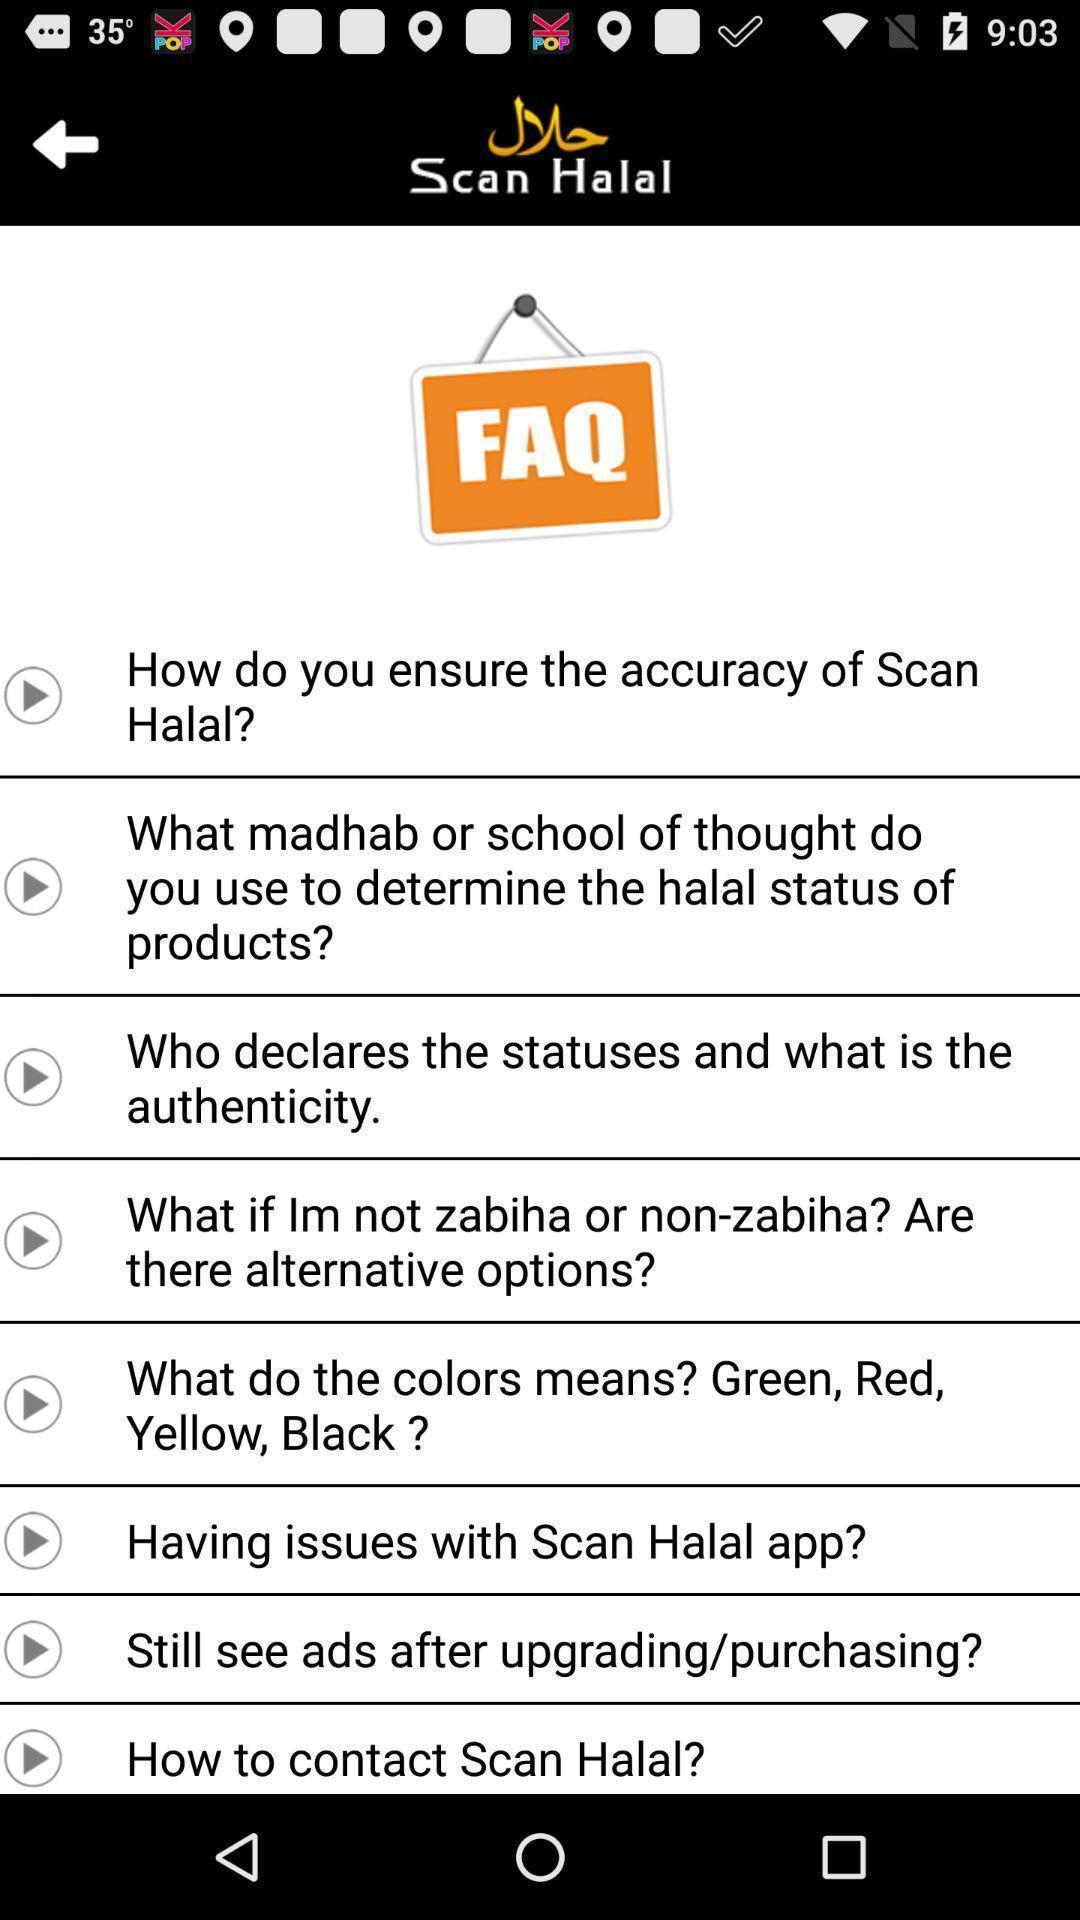What is the overall content of this screenshot? Page showing questions about the barcode scanner app. 